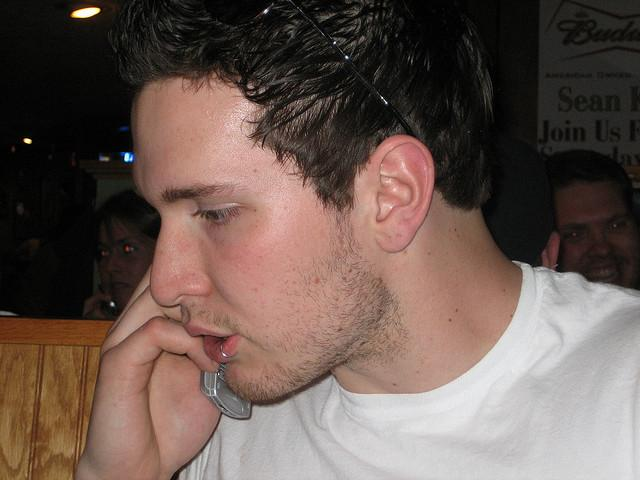What color is the cell phone which the man talks on? Please explain your reasoning. gray. It's also described though as metal or silver when sold as a product. 